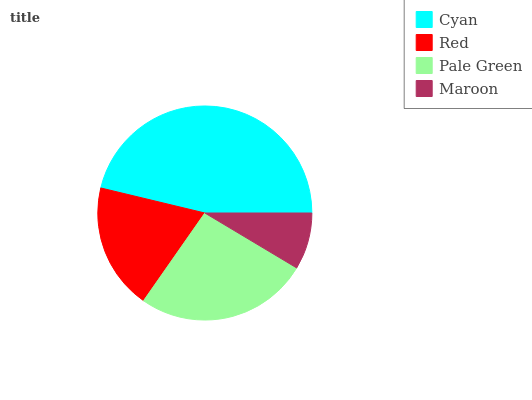Is Maroon the minimum?
Answer yes or no. Yes. Is Cyan the maximum?
Answer yes or no. Yes. Is Red the minimum?
Answer yes or no. No. Is Red the maximum?
Answer yes or no. No. Is Cyan greater than Red?
Answer yes or no. Yes. Is Red less than Cyan?
Answer yes or no. Yes. Is Red greater than Cyan?
Answer yes or no. No. Is Cyan less than Red?
Answer yes or no. No. Is Pale Green the high median?
Answer yes or no. Yes. Is Red the low median?
Answer yes or no. Yes. Is Maroon the high median?
Answer yes or no. No. Is Maroon the low median?
Answer yes or no. No. 